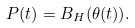Convert formula to latex. <formula><loc_0><loc_0><loc_500><loc_500>P ( t ) = B _ { H } ( \theta ( t ) ) .</formula> 